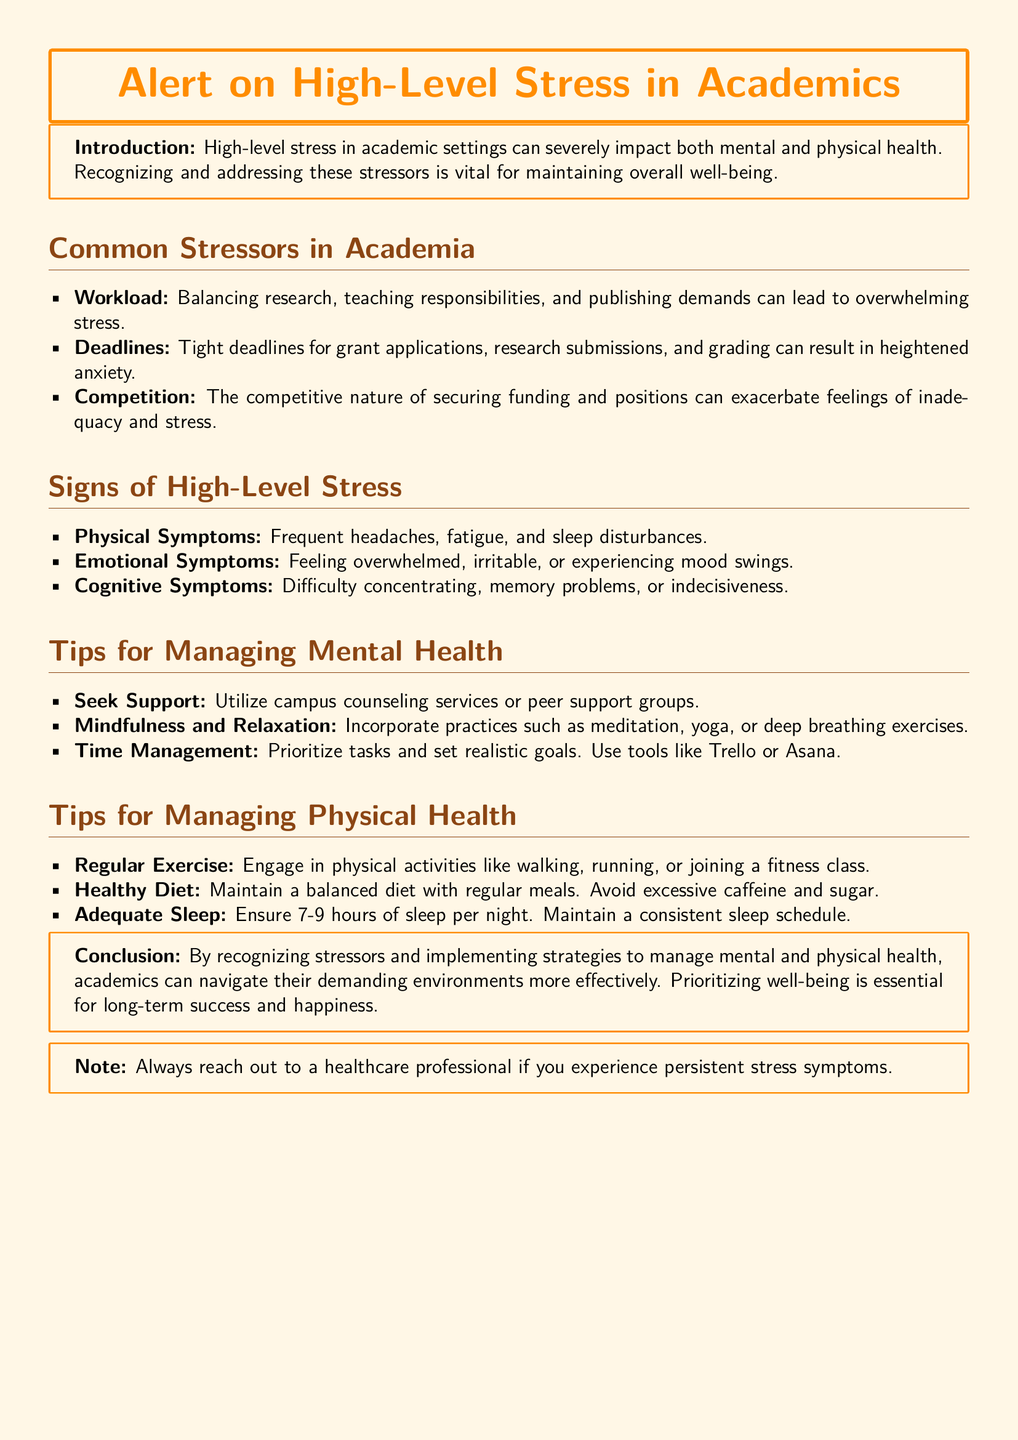what is the title of the document? The title is stated prominently at the beginning of the document inside a tcolorbox.
Answer: Alert on High-Level Stress in Academics what are three common stressors mentioned in academia? The document lists several stressors; the first three clearly stated are workload, deadlines, and competition.
Answer: Workload, deadlines, competition how many hours of sleep should one aim for according to the document? The document specifies the recommended amount of sleep for proper health maintenance.
Answer: 7-9 hours what type of symptoms can manifest due to high-level stress? The document categorizes symptoms into physical, emotional, and cognitive areas.
Answer: Physical, emotional, cognitive which activity is suggested for managing mental health? The document specifically recommends using campus counseling services as a support mechanism for mental health.
Answer: Seek Support what does the document suggest to maintain a balanced diet? It advises on dietary habits to support physical health by emphasizing a balanced diet.
Answer: Maintain a balanced diet which mindfulness practices are recommended in the document? The document lists various methods to manage stress through mindfulness; these include meditation, yoga, and deep breathing exercises.
Answer: Meditation, yoga, deep breathing what should you do if experiencing persistent stress symptoms? The document provides a clear recommendation regarding the actions to take when symptoms persist.
Answer: Reach out to a healthcare professional what is the main focus of the conclusion in the document? The conclusion emphasizes the importance of recognizing stressors and managing health effectively for success and happiness.
Answer: Prioritizing well-being how is the document structured regarding stress management? The document is organized into clearly defined sections addressing different aspects of stress management and symptoms.
Answer: Sections on mental health and physical health management 